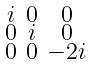<formula> <loc_0><loc_0><loc_500><loc_500>\begin{smallmatrix} i & 0 & 0 \\ 0 & i & 0 \\ 0 & 0 & - 2 i \end{smallmatrix}</formula> 